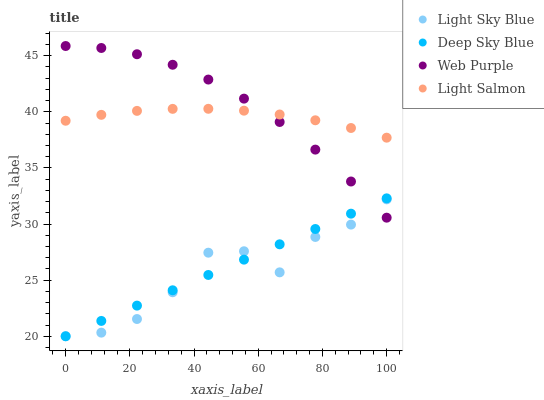Does Light Sky Blue have the minimum area under the curve?
Answer yes or no. Yes. Does Web Purple have the maximum area under the curve?
Answer yes or no. Yes. Does Light Salmon have the minimum area under the curve?
Answer yes or no. No. Does Light Salmon have the maximum area under the curve?
Answer yes or no. No. Is Deep Sky Blue the smoothest?
Answer yes or no. Yes. Is Light Sky Blue the roughest?
Answer yes or no. Yes. Is Light Salmon the smoothest?
Answer yes or no. No. Is Light Salmon the roughest?
Answer yes or no. No. Does Light Sky Blue have the lowest value?
Answer yes or no. Yes. Does Light Salmon have the lowest value?
Answer yes or no. No. Does Web Purple have the highest value?
Answer yes or no. Yes. Does Light Salmon have the highest value?
Answer yes or no. No. Is Light Sky Blue less than Light Salmon?
Answer yes or no. Yes. Is Light Salmon greater than Light Sky Blue?
Answer yes or no. Yes. Does Web Purple intersect Light Salmon?
Answer yes or no. Yes. Is Web Purple less than Light Salmon?
Answer yes or no. No. Is Web Purple greater than Light Salmon?
Answer yes or no. No. Does Light Sky Blue intersect Light Salmon?
Answer yes or no. No. 